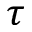<formula> <loc_0><loc_0><loc_500><loc_500>\tau</formula> 